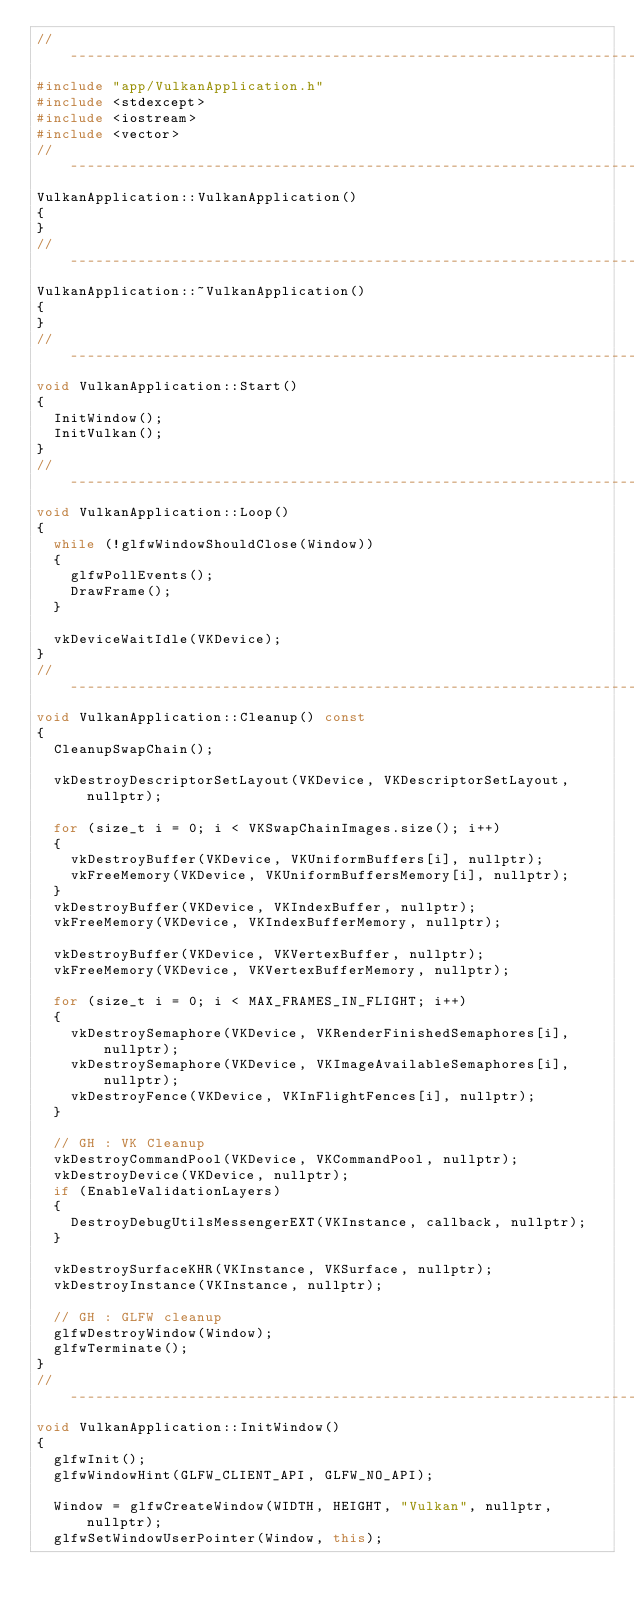<code> <loc_0><loc_0><loc_500><loc_500><_C++_>//-----------------------------------------------------------------------------
#include "app/VulkanApplication.h"
#include <stdexcept>
#include <iostream>
#include <vector>
//-----------------------------------------------------------------------------
VulkanApplication::VulkanApplication()
{
}
//-----------------------------------------------------------------------------
VulkanApplication::~VulkanApplication()
{
}
//-----------------------------------------------------------------------------
void VulkanApplication::Start()
{
	InitWindow();
	InitVulkan();
}
//-----------------------------------------------------------------------------
void VulkanApplication::Loop()
{
	while (!glfwWindowShouldClose(Window))
	{
		glfwPollEvents();
		DrawFrame();
	}

	vkDeviceWaitIdle(VKDevice);
}
//-----------------------------------------------------------------------------
void VulkanApplication::Cleanup() const
{
	CleanupSwapChain();

	vkDestroyDescriptorSetLayout(VKDevice, VKDescriptorSetLayout, nullptr);

	for (size_t i = 0; i < VKSwapChainImages.size(); i++)
	{
		vkDestroyBuffer(VKDevice, VKUniformBuffers[i], nullptr);
		vkFreeMemory(VKDevice, VKUniformBuffersMemory[i], nullptr);
	}
	vkDestroyBuffer(VKDevice, VKIndexBuffer, nullptr);
	vkFreeMemory(VKDevice, VKIndexBufferMemory, nullptr);

	vkDestroyBuffer(VKDevice, VKVertexBuffer, nullptr);
	vkFreeMemory(VKDevice, VKVertexBufferMemory, nullptr);

	for (size_t i = 0; i < MAX_FRAMES_IN_FLIGHT; i++)
	{
		vkDestroySemaphore(VKDevice, VKRenderFinishedSemaphores[i], nullptr);
		vkDestroySemaphore(VKDevice, VKImageAvailableSemaphores[i], nullptr);
		vkDestroyFence(VKDevice, VKInFlightFences[i], nullptr);
	}

	// GH : VK Cleanup
	vkDestroyCommandPool(VKDevice, VKCommandPool, nullptr);
	vkDestroyDevice(VKDevice, nullptr);
	if (EnableValidationLayers)
	{
		DestroyDebugUtilsMessengerEXT(VKInstance, callback, nullptr);
	}
	
	vkDestroySurfaceKHR(VKInstance, VKSurface, nullptr);
	vkDestroyInstance(VKInstance, nullptr);

	// GH : GLFW cleanup
	glfwDestroyWindow(Window); 
	glfwTerminate();
}
//-----------------------------------------------------------------------------
void VulkanApplication::InitWindow() 
{
	glfwInit();
	glfwWindowHint(GLFW_CLIENT_API, GLFW_NO_API);

	Window = glfwCreateWindow(WIDTH, HEIGHT, "Vulkan", nullptr, nullptr);
	glfwSetWindowUserPointer(Window, this);</code> 